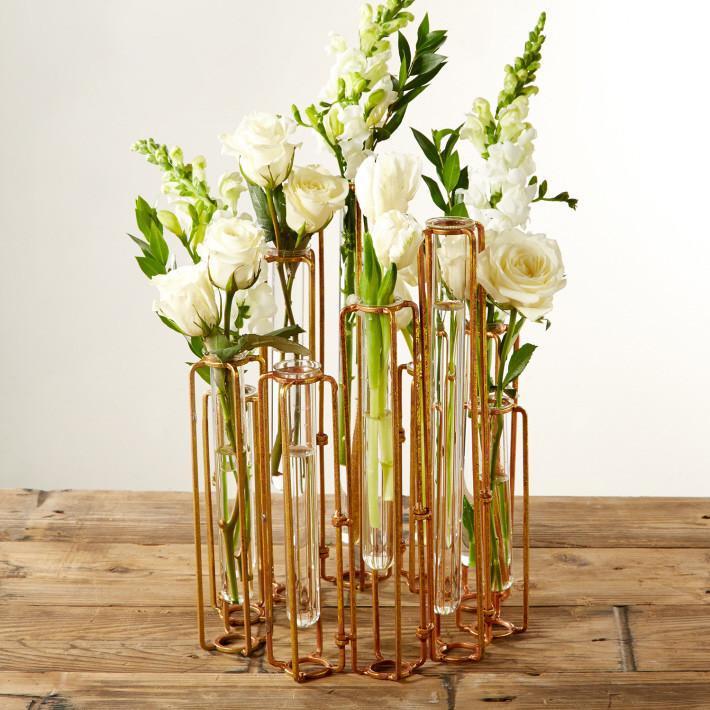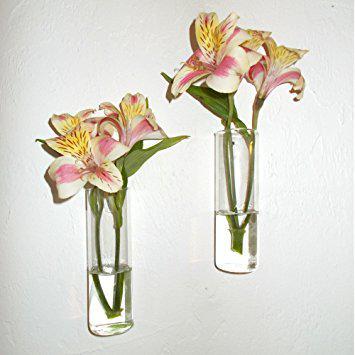The first image is the image on the left, the second image is the image on the right. For the images shown, is this caption "One image includes a clear glass vase containing only bright yellow flowers standing in water." true? Answer yes or no. No. The first image is the image on the left, the second image is the image on the right. Examine the images to the left and right. Is the description "Yellow flowers sit in some of the vases." accurate? Answer yes or no. No. 